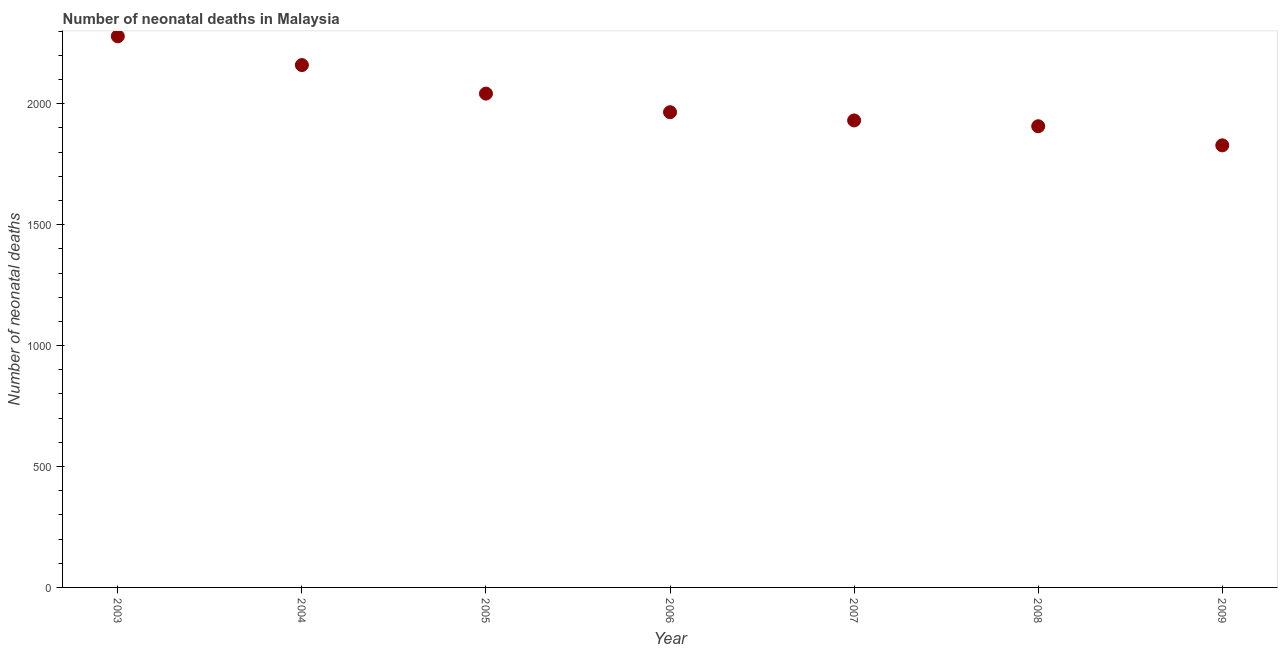What is the number of neonatal deaths in 2004?
Offer a terse response. 2160. Across all years, what is the maximum number of neonatal deaths?
Make the answer very short. 2279. Across all years, what is the minimum number of neonatal deaths?
Provide a short and direct response. 1828. What is the sum of the number of neonatal deaths?
Give a very brief answer. 1.41e+04. What is the difference between the number of neonatal deaths in 2006 and 2008?
Your answer should be very brief. 58. What is the average number of neonatal deaths per year?
Your answer should be compact. 2016. What is the median number of neonatal deaths?
Your answer should be very brief. 1965. In how many years, is the number of neonatal deaths greater than 2200 ?
Offer a very short reply. 1. Do a majority of the years between 2005 and 2006 (inclusive) have number of neonatal deaths greater than 600 ?
Keep it short and to the point. Yes. What is the ratio of the number of neonatal deaths in 2005 to that in 2008?
Make the answer very short. 1.07. Is the number of neonatal deaths in 2005 less than that in 2009?
Give a very brief answer. No. What is the difference between the highest and the second highest number of neonatal deaths?
Provide a short and direct response. 119. Is the sum of the number of neonatal deaths in 2008 and 2009 greater than the maximum number of neonatal deaths across all years?
Your response must be concise. Yes. What is the difference between the highest and the lowest number of neonatal deaths?
Your answer should be compact. 451. In how many years, is the number of neonatal deaths greater than the average number of neonatal deaths taken over all years?
Your answer should be very brief. 3. How many years are there in the graph?
Give a very brief answer. 7. What is the difference between two consecutive major ticks on the Y-axis?
Your answer should be very brief. 500. Are the values on the major ticks of Y-axis written in scientific E-notation?
Offer a very short reply. No. Does the graph contain any zero values?
Ensure brevity in your answer.  No. What is the title of the graph?
Your answer should be compact. Number of neonatal deaths in Malaysia. What is the label or title of the Y-axis?
Offer a terse response. Number of neonatal deaths. What is the Number of neonatal deaths in 2003?
Provide a short and direct response. 2279. What is the Number of neonatal deaths in 2004?
Offer a terse response. 2160. What is the Number of neonatal deaths in 2005?
Provide a short and direct response. 2042. What is the Number of neonatal deaths in 2006?
Your answer should be compact. 1965. What is the Number of neonatal deaths in 2007?
Keep it short and to the point. 1931. What is the Number of neonatal deaths in 2008?
Ensure brevity in your answer.  1907. What is the Number of neonatal deaths in 2009?
Your answer should be very brief. 1828. What is the difference between the Number of neonatal deaths in 2003 and 2004?
Keep it short and to the point. 119. What is the difference between the Number of neonatal deaths in 2003 and 2005?
Ensure brevity in your answer.  237. What is the difference between the Number of neonatal deaths in 2003 and 2006?
Your answer should be very brief. 314. What is the difference between the Number of neonatal deaths in 2003 and 2007?
Offer a terse response. 348. What is the difference between the Number of neonatal deaths in 2003 and 2008?
Ensure brevity in your answer.  372. What is the difference between the Number of neonatal deaths in 2003 and 2009?
Your response must be concise. 451. What is the difference between the Number of neonatal deaths in 2004 and 2005?
Provide a short and direct response. 118. What is the difference between the Number of neonatal deaths in 2004 and 2006?
Your answer should be very brief. 195. What is the difference between the Number of neonatal deaths in 2004 and 2007?
Your answer should be compact. 229. What is the difference between the Number of neonatal deaths in 2004 and 2008?
Offer a terse response. 253. What is the difference between the Number of neonatal deaths in 2004 and 2009?
Your answer should be compact. 332. What is the difference between the Number of neonatal deaths in 2005 and 2006?
Your response must be concise. 77. What is the difference between the Number of neonatal deaths in 2005 and 2007?
Ensure brevity in your answer.  111. What is the difference between the Number of neonatal deaths in 2005 and 2008?
Provide a succinct answer. 135. What is the difference between the Number of neonatal deaths in 2005 and 2009?
Your answer should be compact. 214. What is the difference between the Number of neonatal deaths in 2006 and 2009?
Give a very brief answer. 137. What is the difference between the Number of neonatal deaths in 2007 and 2009?
Your response must be concise. 103. What is the difference between the Number of neonatal deaths in 2008 and 2009?
Provide a succinct answer. 79. What is the ratio of the Number of neonatal deaths in 2003 to that in 2004?
Your answer should be very brief. 1.05. What is the ratio of the Number of neonatal deaths in 2003 to that in 2005?
Ensure brevity in your answer.  1.12. What is the ratio of the Number of neonatal deaths in 2003 to that in 2006?
Your answer should be compact. 1.16. What is the ratio of the Number of neonatal deaths in 2003 to that in 2007?
Provide a succinct answer. 1.18. What is the ratio of the Number of neonatal deaths in 2003 to that in 2008?
Give a very brief answer. 1.2. What is the ratio of the Number of neonatal deaths in 2003 to that in 2009?
Give a very brief answer. 1.25. What is the ratio of the Number of neonatal deaths in 2004 to that in 2005?
Provide a short and direct response. 1.06. What is the ratio of the Number of neonatal deaths in 2004 to that in 2006?
Give a very brief answer. 1.1. What is the ratio of the Number of neonatal deaths in 2004 to that in 2007?
Ensure brevity in your answer.  1.12. What is the ratio of the Number of neonatal deaths in 2004 to that in 2008?
Ensure brevity in your answer.  1.13. What is the ratio of the Number of neonatal deaths in 2004 to that in 2009?
Your answer should be very brief. 1.18. What is the ratio of the Number of neonatal deaths in 2005 to that in 2006?
Make the answer very short. 1.04. What is the ratio of the Number of neonatal deaths in 2005 to that in 2007?
Provide a short and direct response. 1.06. What is the ratio of the Number of neonatal deaths in 2005 to that in 2008?
Your response must be concise. 1.07. What is the ratio of the Number of neonatal deaths in 2005 to that in 2009?
Offer a very short reply. 1.12. What is the ratio of the Number of neonatal deaths in 2006 to that in 2008?
Your answer should be very brief. 1.03. What is the ratio of the Number of neonatal deaths in 2006 to that in 2009?
Keep it short and to the point. 1.07. What is the ratio of the Number of neonatal deaths in 2007 to that in 2009?
Provide a short and direct response. 1.06. What is the ratio of the Number of neonatal deaths in 2008 to that in 2009?
Your answer should be compact. 1.04. 